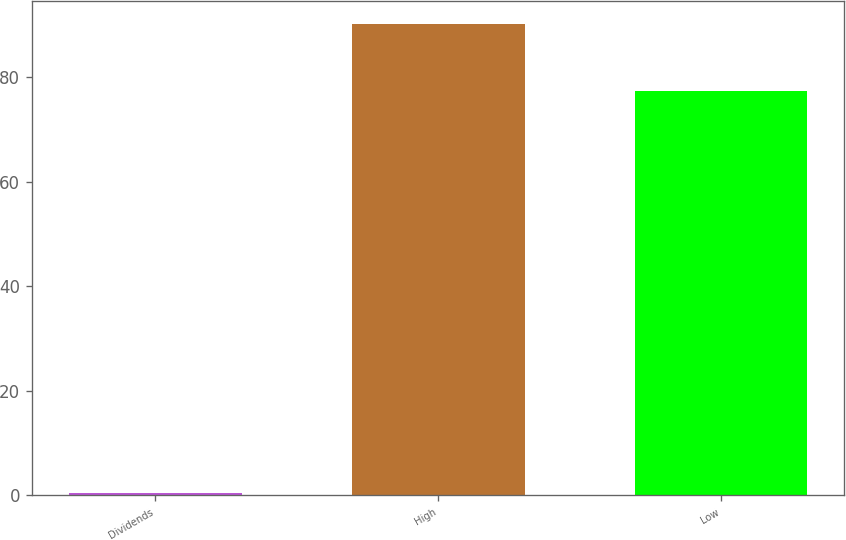Convert chart. <chart><loc_0><loc_0><loc_500><loc_500><bar_chart><fcel>Dividends<fcel>High<fcel>Low<nl><fcel>0.55<fcel>90.14<fcel>77.29<nl></chart> 